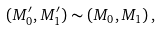Convert formula to latex. <formula><loc_0><loc_0><loc_500><loc_500>( M _ { 0 } ^ { \prime } , M _ { 1 } ^ { \prime } ) \sim ( M _ { 0 } , M _ { 1 } ) \, ,</formula> 